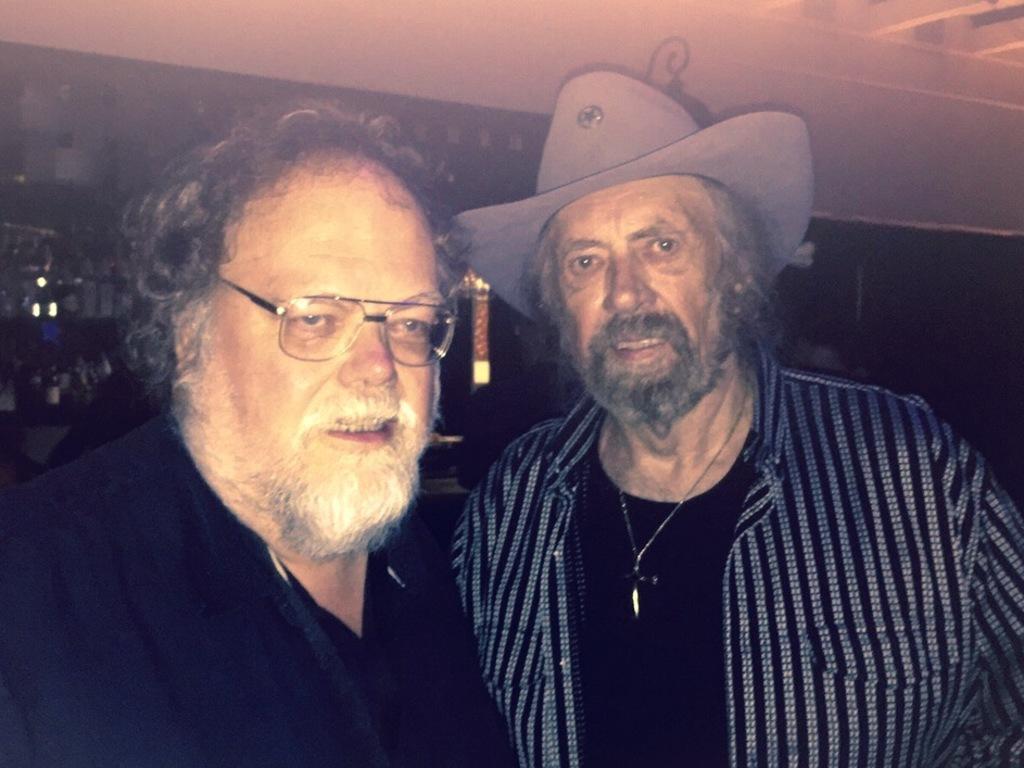Can you describe this image briefly? In this image we can see a man wearing the glasses and we can also see another man wearing the hat. The background is not clear. At the top we can see the ceiling. 